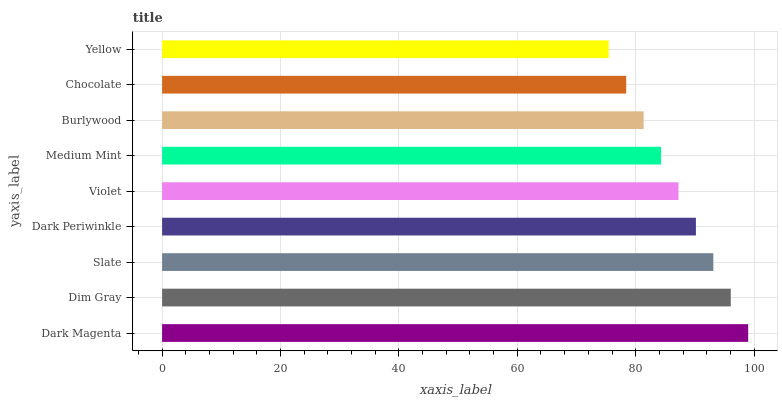Is Yellow the minimum?
Answer yes or no. Yes. Is Dark Magenta the maximum?
Answer yes or no. Yes. Is Dim Gray the minimum?
Answer yes or no. No. Is Dim Gray the maximum?
Answer yes or no. No. Is Dark Magenta greater than Dim Gray?
Answer yes or no. Yes. Is Dim Gray less than Dark Magenta?
Answer yes or no. Yes. Is Dim Gray greater than Dark Magenta?
Answer yes or no. No. Is Dark Magenta less than Dim Gray?
Answer yes or no. No. Is Violet the high median?
Answer yes or no. Yes. Is Violet the low median?
Answer yes or no. Yes. Is Slate the high median?
Answer yes or no. No. Is Burlywood the low median?
Answer yes or no. No. 